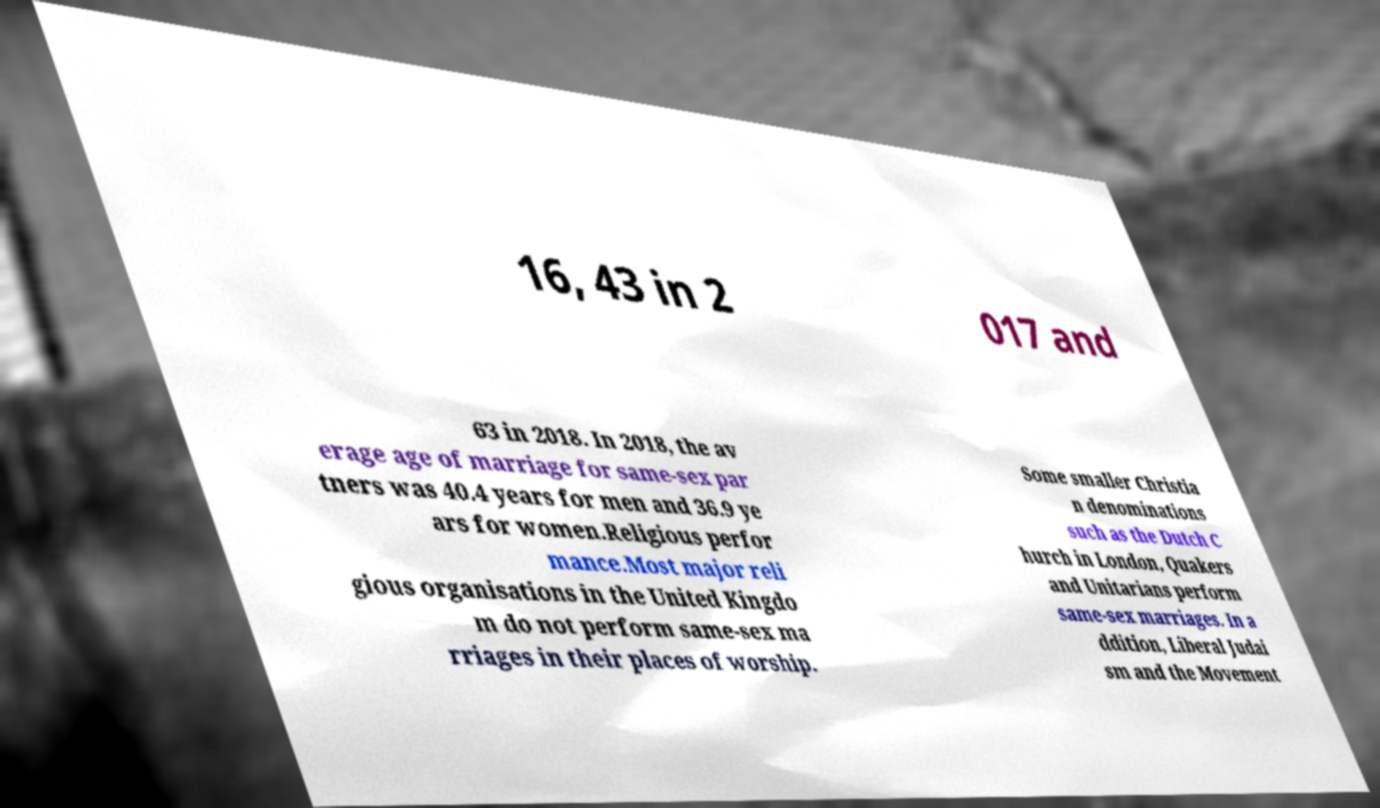Please read and relay the text visible in this image. What does it say? 16, 43 in 2 017 and 63 in 2018. In 2018, the av erage age of marriage for same-sex par tners was 40.4 years for men and 36.9 ye ars for women.Religious perfor mance.Most major reli gious organisations in the United Kingdo m do not perform same-sex ma rriages in their places of worship. Some smaller Christia n denominations such as the Dutch C hurch in London, Quakers and Unitarians perform same-sex marriages. In a ddition, Liberal Judai sm and the Movement 